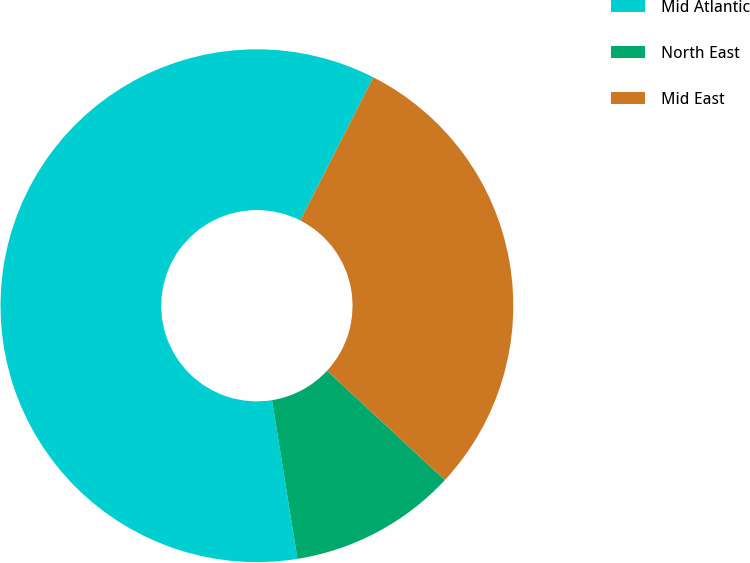Convert chart. <chart><loc_0><loc_0><loc_500><loc_500><pie_chart><fcel>Mid Atlantic<fcel>North East<fcel>Mid East<nl><fcel>60.03%<fcel>10.57%<fcel>29.4%<nl></chart> 